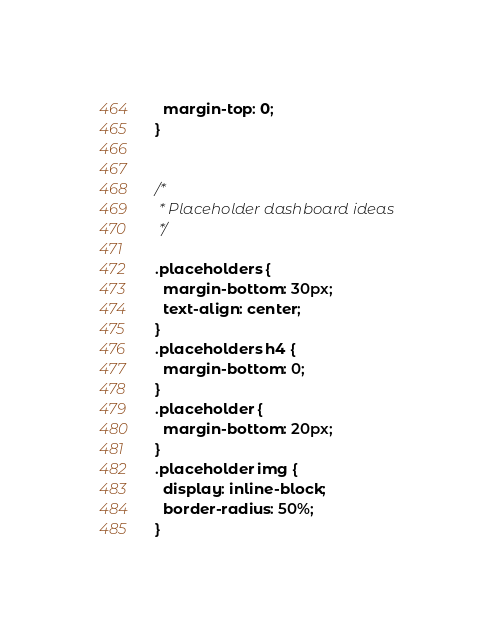<code> <loc_0><loc_0><loc_500><loc_500><_CSS_>  margin-top: 0;
}


/*
 * Placeholder dashboard ideas
 */

.placeholders {
  margin-bottom: 30px;
  text-align: center;
}
.placeholders h4 {
  margin-bottom: 0;
}
.placeholder {
  margin-bottom: 20px;
}
.placeholder img {
  display: inline-block;
  border-radius: 50%;
}</code> 